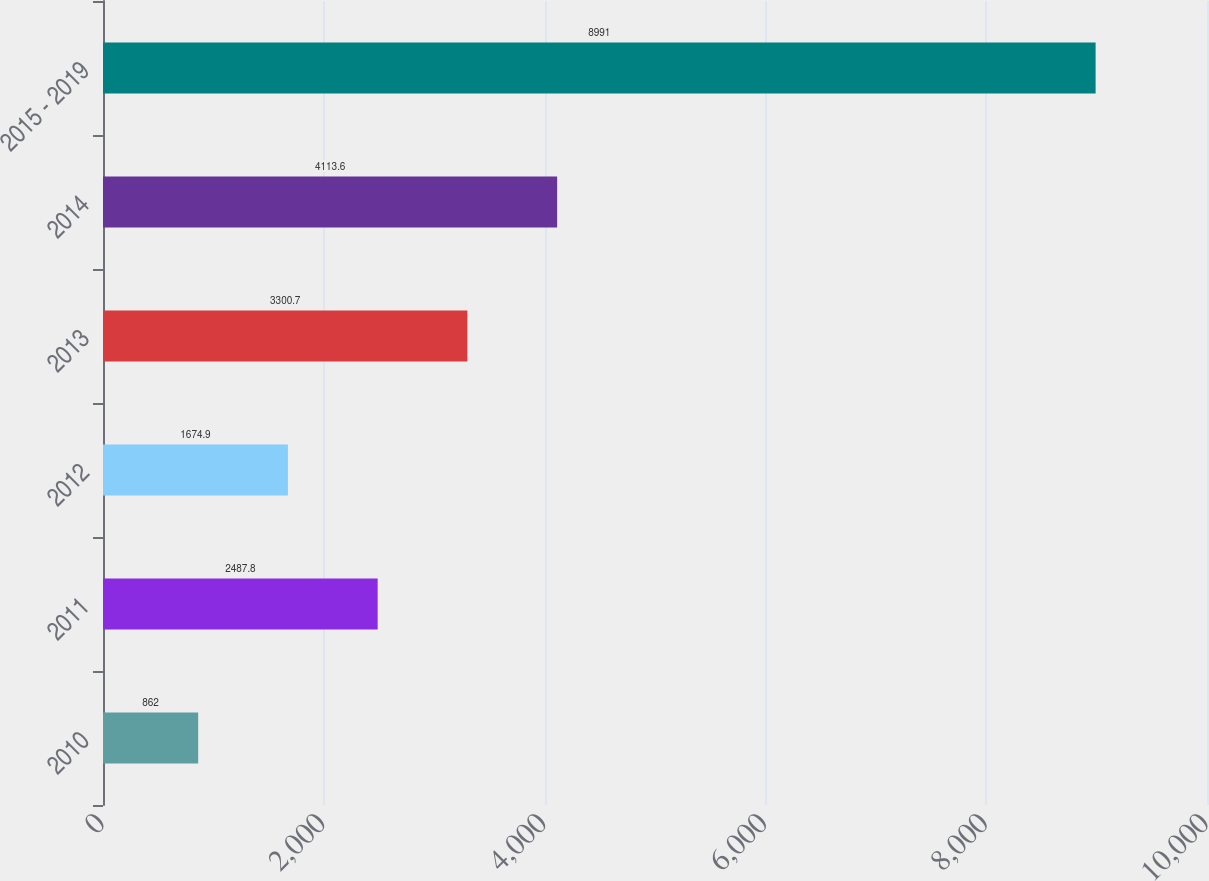Convert chart. <chart><loc_0><loc_0><loc_500><loc_500><bar_chart><fcel>2010<fcel>2011<fcel>2012<fcel>2013<fcel>2014<fcel>2015 - 2019<nl><fcel>862<fcel>2487.8<fcel>1674.9<fcel>3300.7<fcel>4113.6<fcel>8991<nl></chart> 